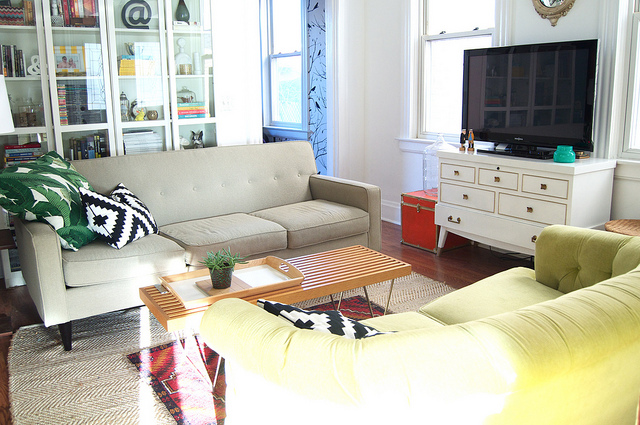Can you describe the style or theme of the decor in this room? The room features a mid-century modern aesthetic, characterized by the clean lines of the furniture and the vintage-inspired accents. The use of a bold, geometric-patterned rug and the inclusion of house plants add energy and a touch of nature to the space, creating a harmonious blend of retro and contemporary styles. 